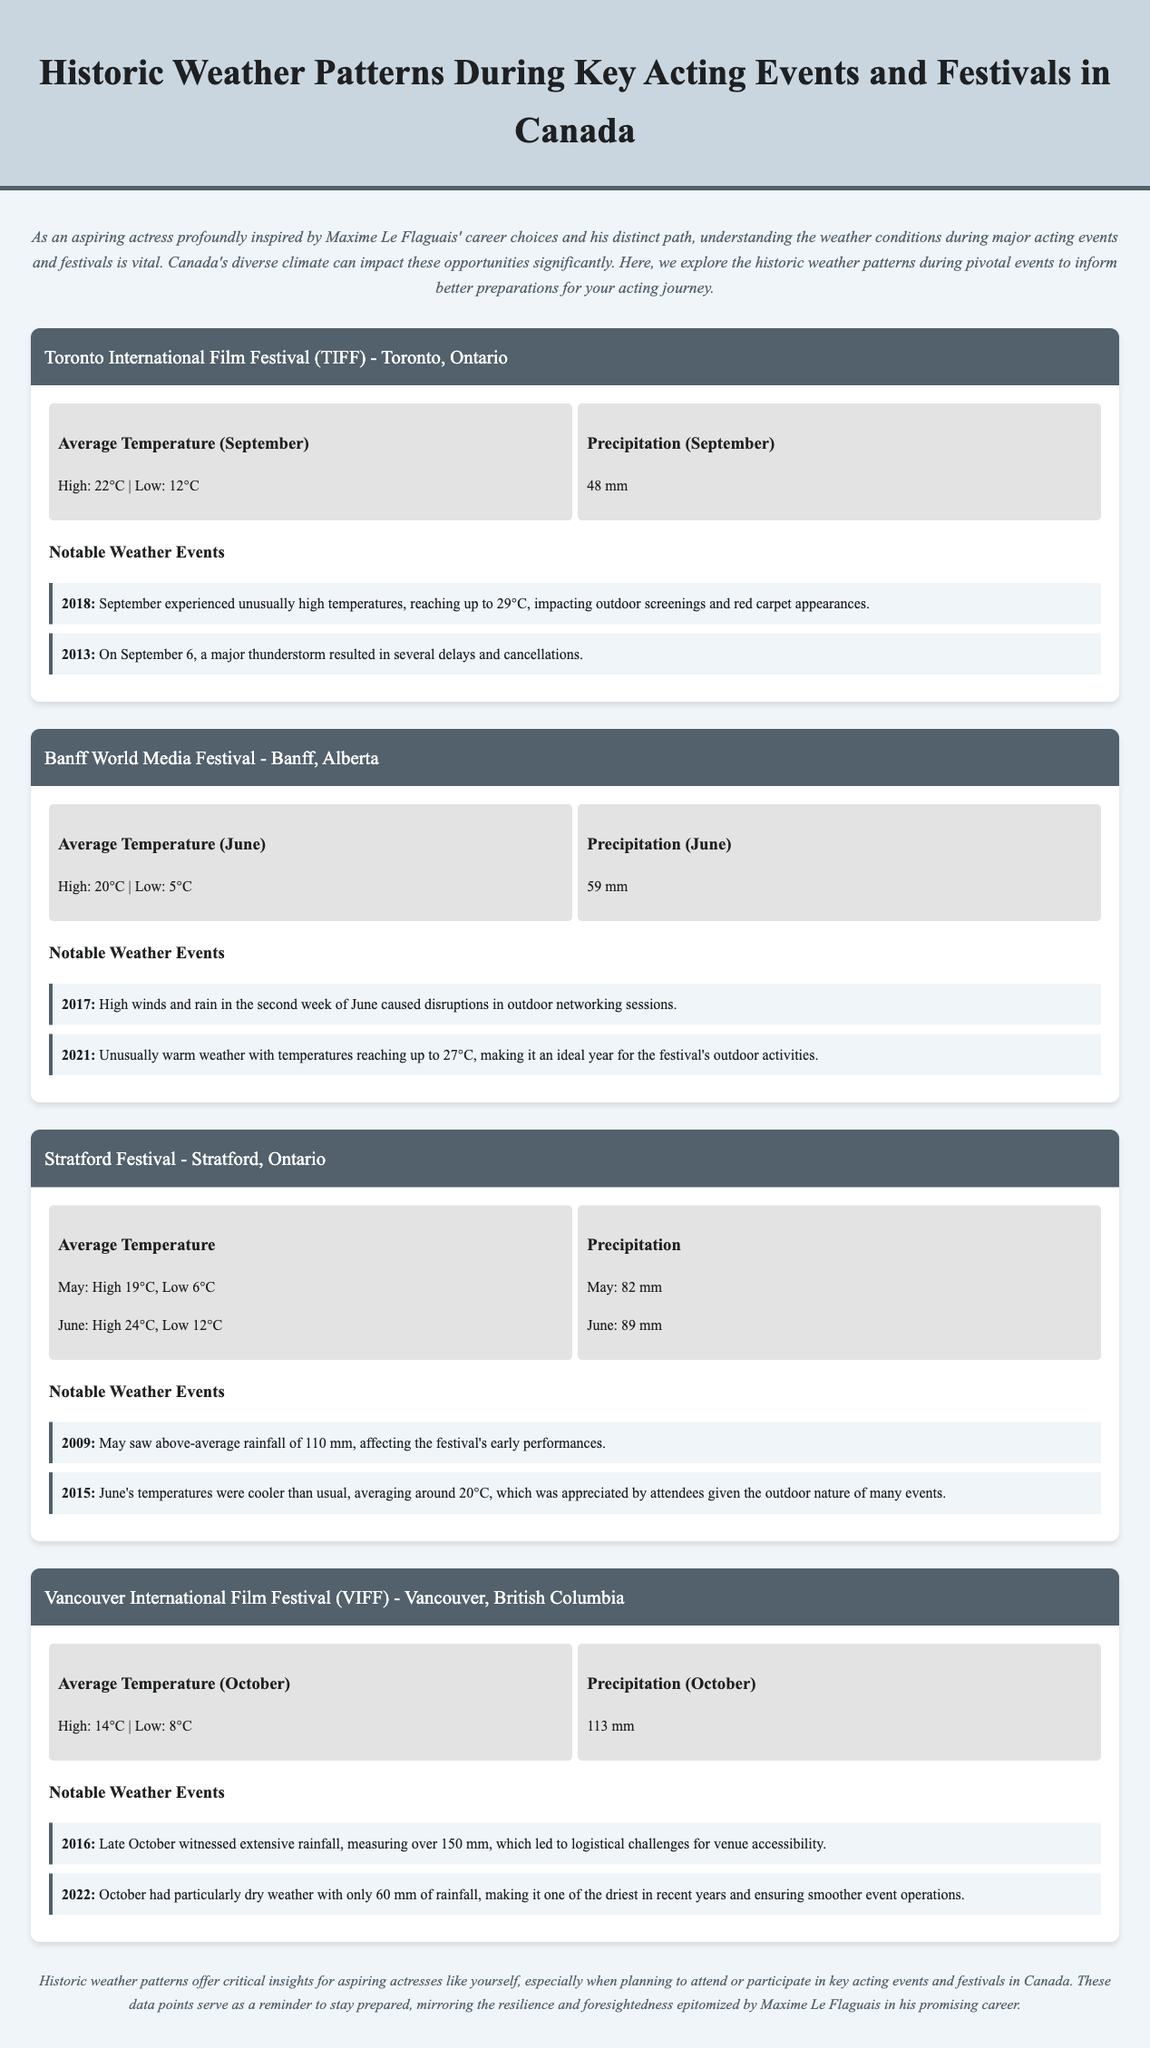What is the average high temperature for TIFF in September? The average high temperature for TIFF in September is listed as 22°C.
Answer: 22°C What was the notable weather event in 2018 during TIFF? The notable weather event in 2018 was unusually high temperatures reaching up to 29°C.
Answer: Unusually high temperatures What is the average precipitation in June for the Banff World Media Festival? The average precipitation in June for the Banff World Media Festival is 59 mm.
Answer: 59 mm What was the highest temperature recorded in 2021 during the Banff festival? The highest temperature recorded in 2021 during the Banff festival was 27°C.
Answer: 27°C How much rainfall was observed during the 2016 VIFF? The rainfall observed during the 2016 VIFF was over 150 mm.
Answer: Over 150 mm What was the total precipitation recorded during May for the Stratford Festival? The total precipitation recorded during May for the Stratford Festival is 82 mm.
Answer: 82 mm Which festival experienced disruptions due to a thunderstorm in 2013? The festival that experienced disruptions due to a thunderstorm in 2013 is the Toronto International Film Festival (TIFF).
Answer: Toronto International Film Festival (TIFF) What is the average low temperature for the Stratford Festival in June? The average low temperature for the Stratford Festival in June is 12°C.
Answer: 12°C What was the notable weather event for the Stratford Festival in 2009? The notable weather event for the Stratford Festival in 2009 was above-average rainfall of 110 mm.
Answer: Above-average rainfall of 110 mm 